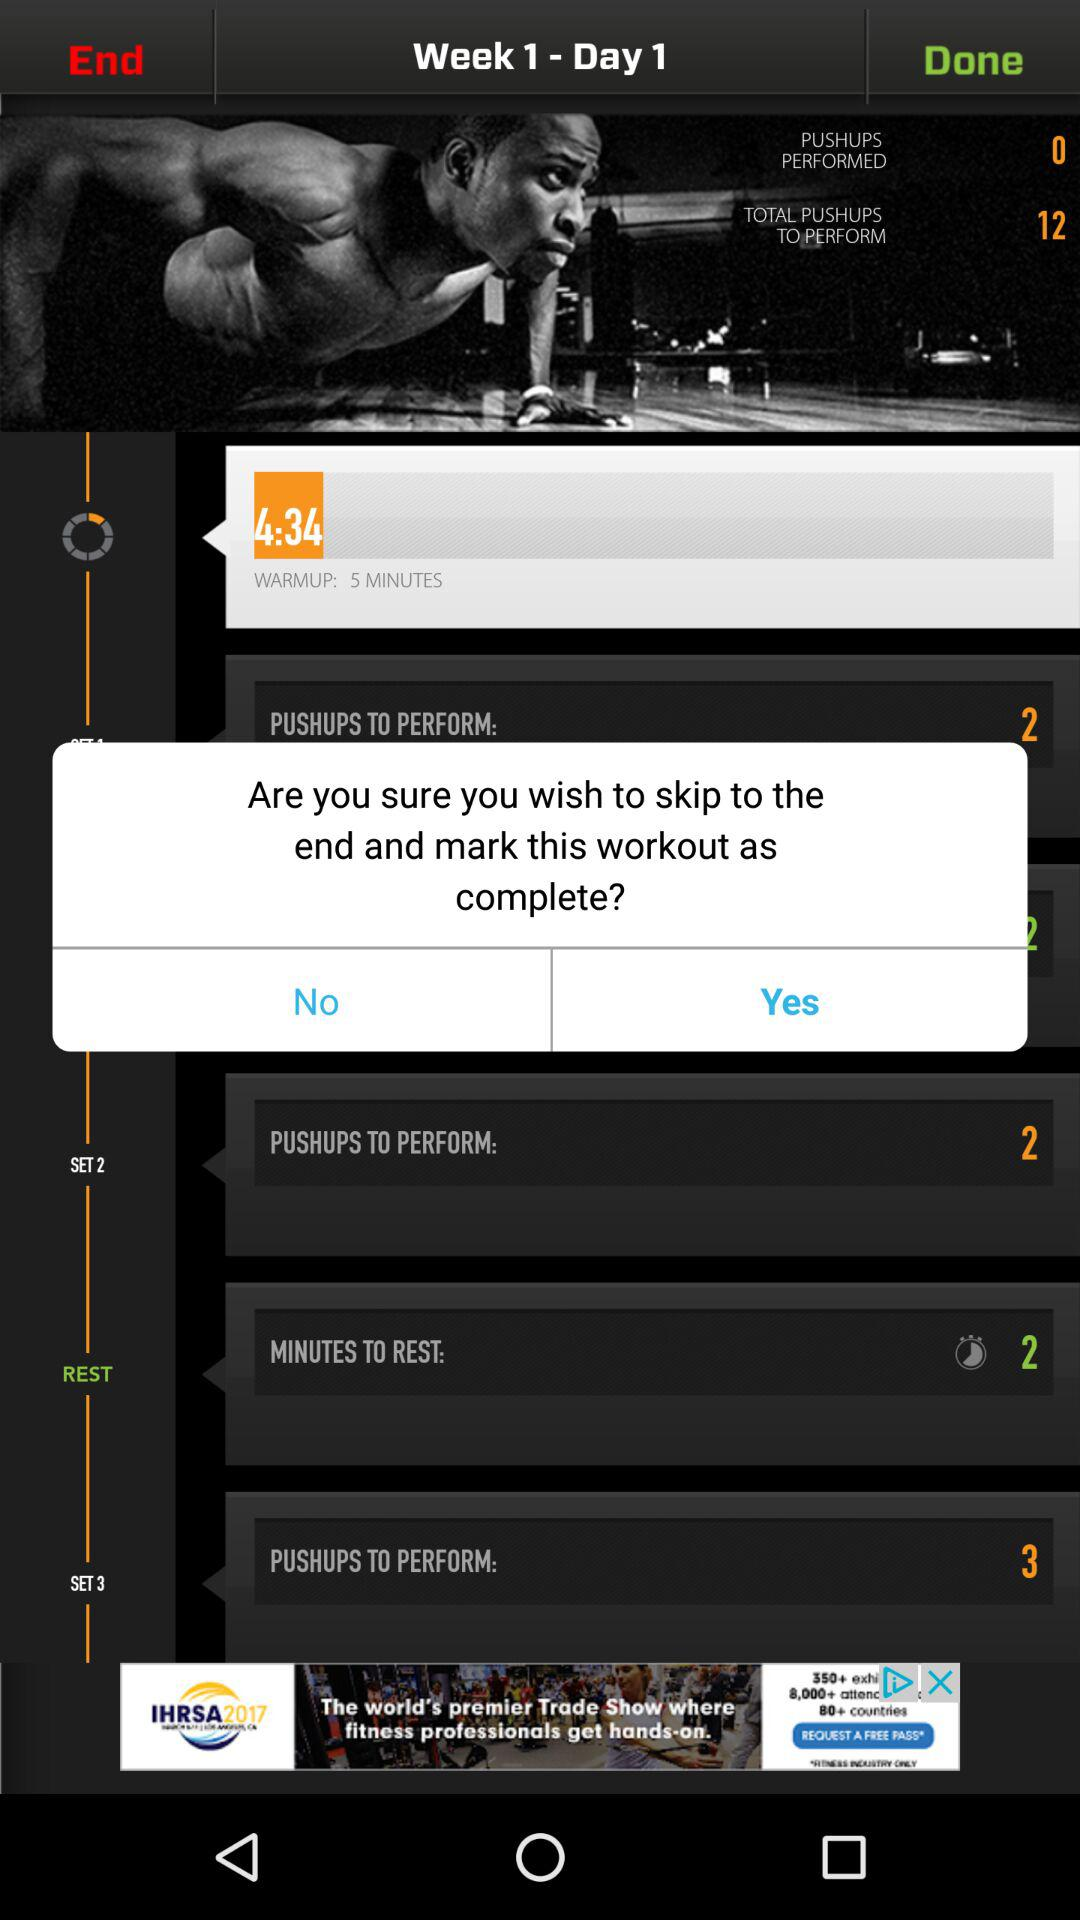What is the total number of pushups to be performed? The total number of pushups to be performed is 12. 